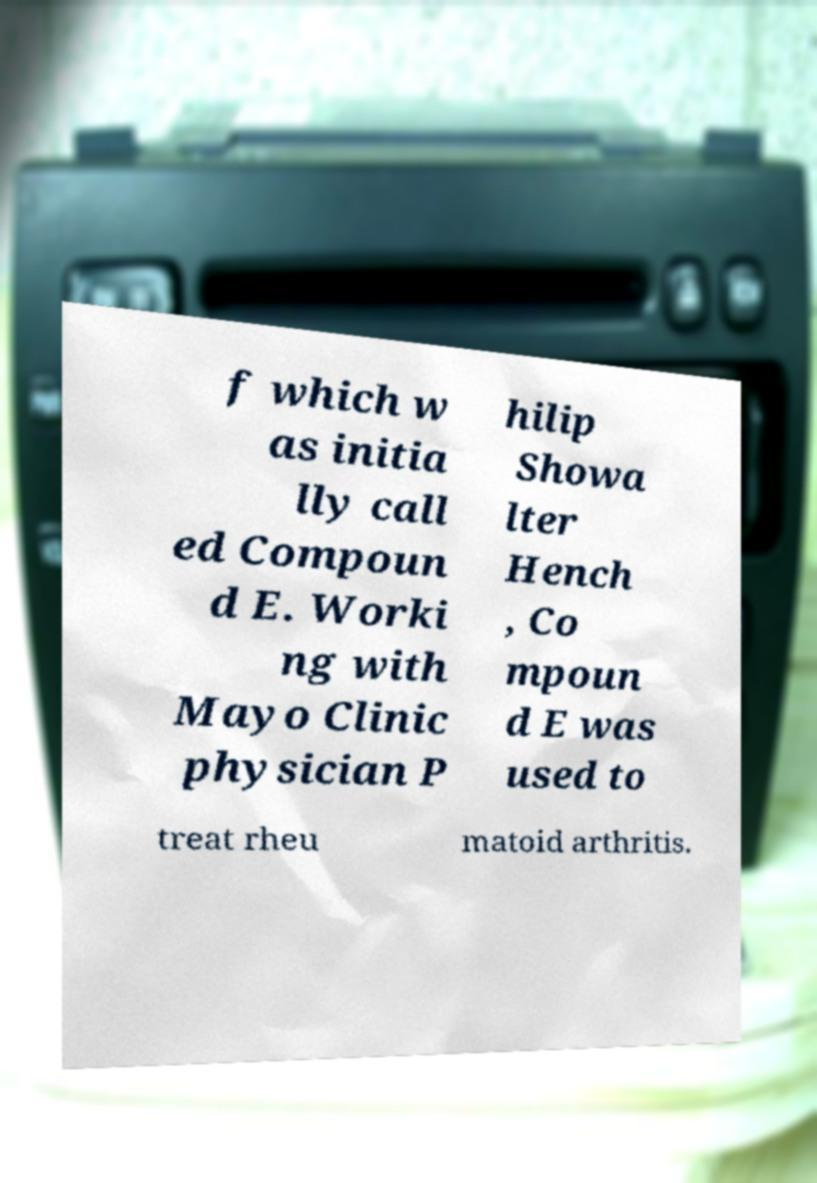Can you accurately transcribe the text from the provided image for me? f which w as initia lly call ed Compoun d E. Worki ng with Mayo Clinic physician P hilip Showa lter Hench , Co mpoun d E was used to treat rheu matoid arthritis. 